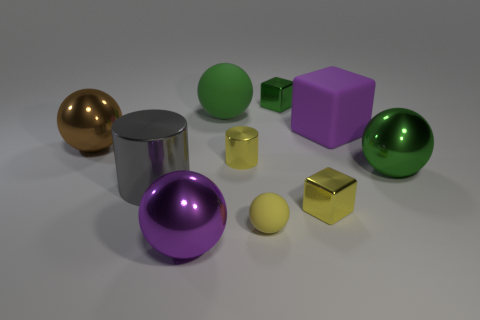Subtract all green matte spheres. How many spheres are left? 4 Subtract 3 spheres. How many spheres are left? 2 Subtract all green spheres. How many spheres are left? 3 Subtract all gray balls. How many green cubes are left? 1 Subtract all cylinders. How many objects are left? 8 Subtract all green cylinders. Subtract all brown spheres. How many cylinders are left? 2 Subtract all tiny green rubber cylinders. Subtract all yellow objects. How many objects are left? 7 Add 2 cylinders. How many cylinders are left? 4 Add 5 large green rubber objects. How many large green rubber objects exist? 6 Subtract 0 purple cylinders. How many objects are left? 10 